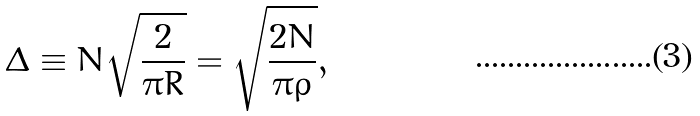Convert formula to latex. <formula><loc_0><loc_0><loc_500><loc_500>\Delta \equiv N \sqrt { \frac { 2 } { \pi R } } = \sqrt { \frac { 2 N } { \pi \rho } } ,</formula> 